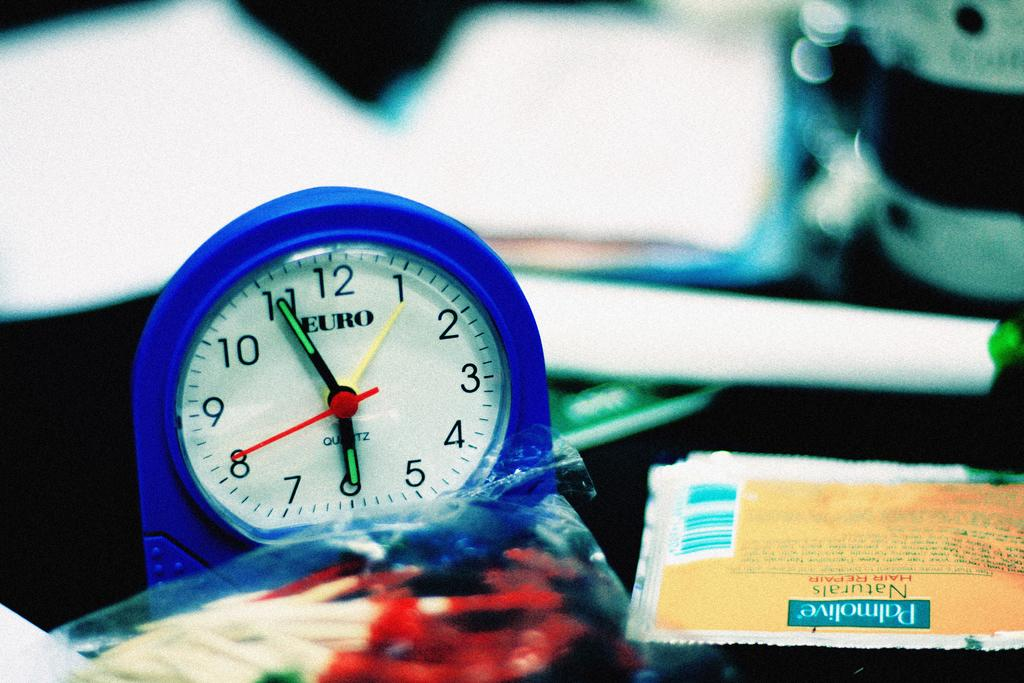<image>
Give a short and clear explanation of the subsequent image. A Euro clock is next to a Palmolive hair repair packet 